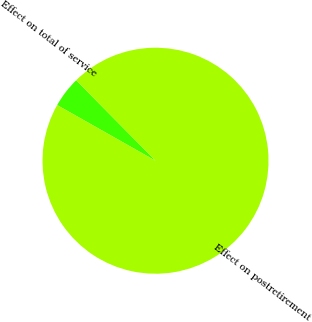Convert chart. <chart><loc_0><loc_0><loc_500><loc_500><pie_chart><fcel>Effect on total of service<fcel>Effect on postretirement<nl><fcel>4.41%<fcel>95.59%<nl></chart> 